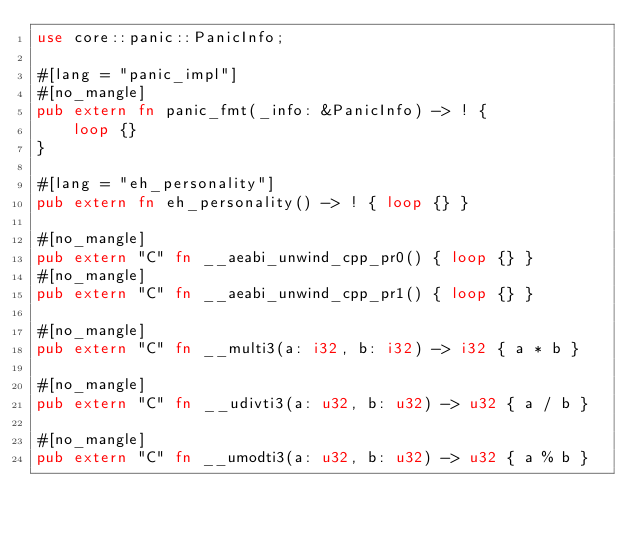Convert code to text. <code><loc_0><loc_0><loc_500><loc_500><_Rust_>use core::panic::PanicInfo;

#[lang = "panic_impl"]
#[no_mangle]
pub extern fn panic_fmt(_info: &PanicInfo) -> ! {
    loop {}
}

#[lang = "eh_personality"]
pub extern fn eh_personality() -> ! { loop {} }

#[no_mangle]
pub extern "C" fn __aeabi_unwind_cpp_pr0() { loop {} }
#[no_mangle]
pub extern "C" fn __aeabi_unwind_cpp_pr1() { loop {} }

#[no_mangle]
pub extern "C" fn __multi3(a: i32, b: i32) -> i32 { a * b }

#[no_mangle]
pub extern "C" fn __udivti3(a: u32, b: u32) -> u32 { a / b }

#[no_mangle]
pub extern "C" fn __umodti3(a: u32, b: u32) -> u32 { a % b }
</code> 